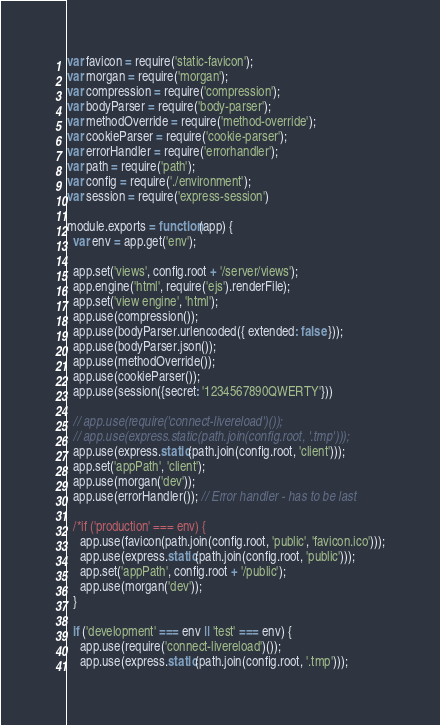<code> <loc_0><loc_0><loc_500><loc_500><_JavaScript_>var favicon = require('static-favicon');
var morgan = require('morgan');
var compression = require('compression');
var bodyParser = require('body-parser');
var methodOverride = require('method-override');
var cookieParser = require('cookie-parser');
var errorHandler = require('errorhandler');
var path = require('path');
var config = require('./environment');
var session = require('express-session')

module.exports = function(app) {
  var env = app.get('env');

  app.set('views', config.root + '/server/views');
  app.engine('html', require('ejs').renderFile);
  app.set('view engine', 'html');
  app.use(compression());
  app.use(bodyParser.urlencoded({ extended: false }));
  app.use(bodyParser.json());
  app.use(methodOverride());
  app.use(cookieParser());
  app.use(session({secret: '1234567890QWERTY'}))

  // app.use(require('connect-livereload')());
  // app.use(express.static(path.join(config.root, '.tmp')));
  app.use(express.static(path.join(config.root, 'client')));
  app.set('appPath', 'client');
  app.use(morgan('dev'));
  app.use(errorHandler()); // Error handler - has to be last

  /*if ('production' === env) {
    app.use(favicon(path.join(config.root, 'public', 'favicon.ico')));
    app.use(express.static(path.join(config.root, 'public')));
    app.set('appPath', config.root + '/public');
    app.use(morgan('dev'));
  }

  if ('development' === env || 'test' === env) {
    app.use(require('connect-livereload')());
    app.use(express.static(path.join(config.root, '.tmp')));</code> 